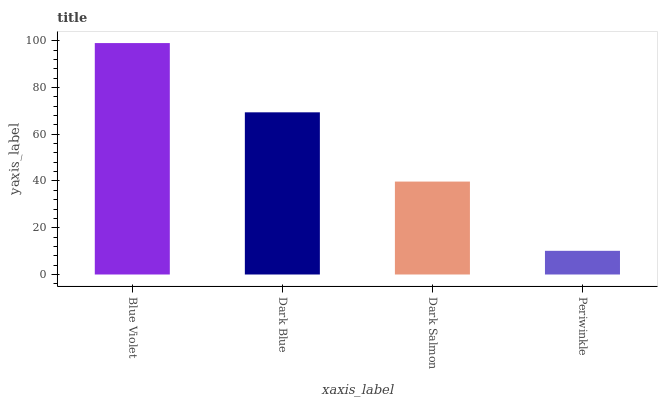Is Periwinkle the minimum?
Answer yes or no. Yes. Is Blue Violet the maximum?
Answer yes or no. Yes. Is Dark Blue the minimum?
Answer yes or no. No. Is Dark Blue the maximum?
Answer yes or no. No. Is Blue Violet greater than Dark Blue?
Answer yes or no. Yes. Is Dark Blue less than Blue Violet?
Answer yes or no. Yes. Is Dark Blue greater than Blue Violet?
Answer yes or no. No. Is Blue Violet less than Dark Blue?
Answer yes or no. No. Is Dark Blue the high median?
Answer yes or no. Yes. Is Dark Salmon the low median?
Answer yes or no. Yes. Is Dark Salmon the high median?
Answer yes or no. No. Is Dark Blue the low median?
Answer yes or no. No. 